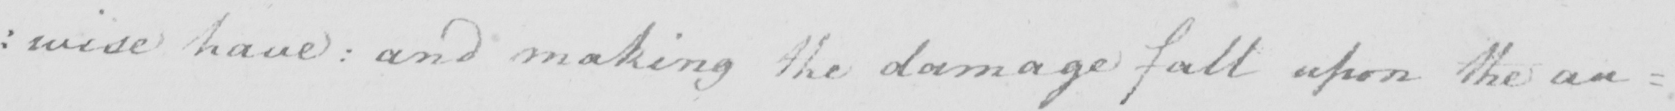Please provide the text content of this handwritten line. :wise have: and making the damage fall upon the au= 